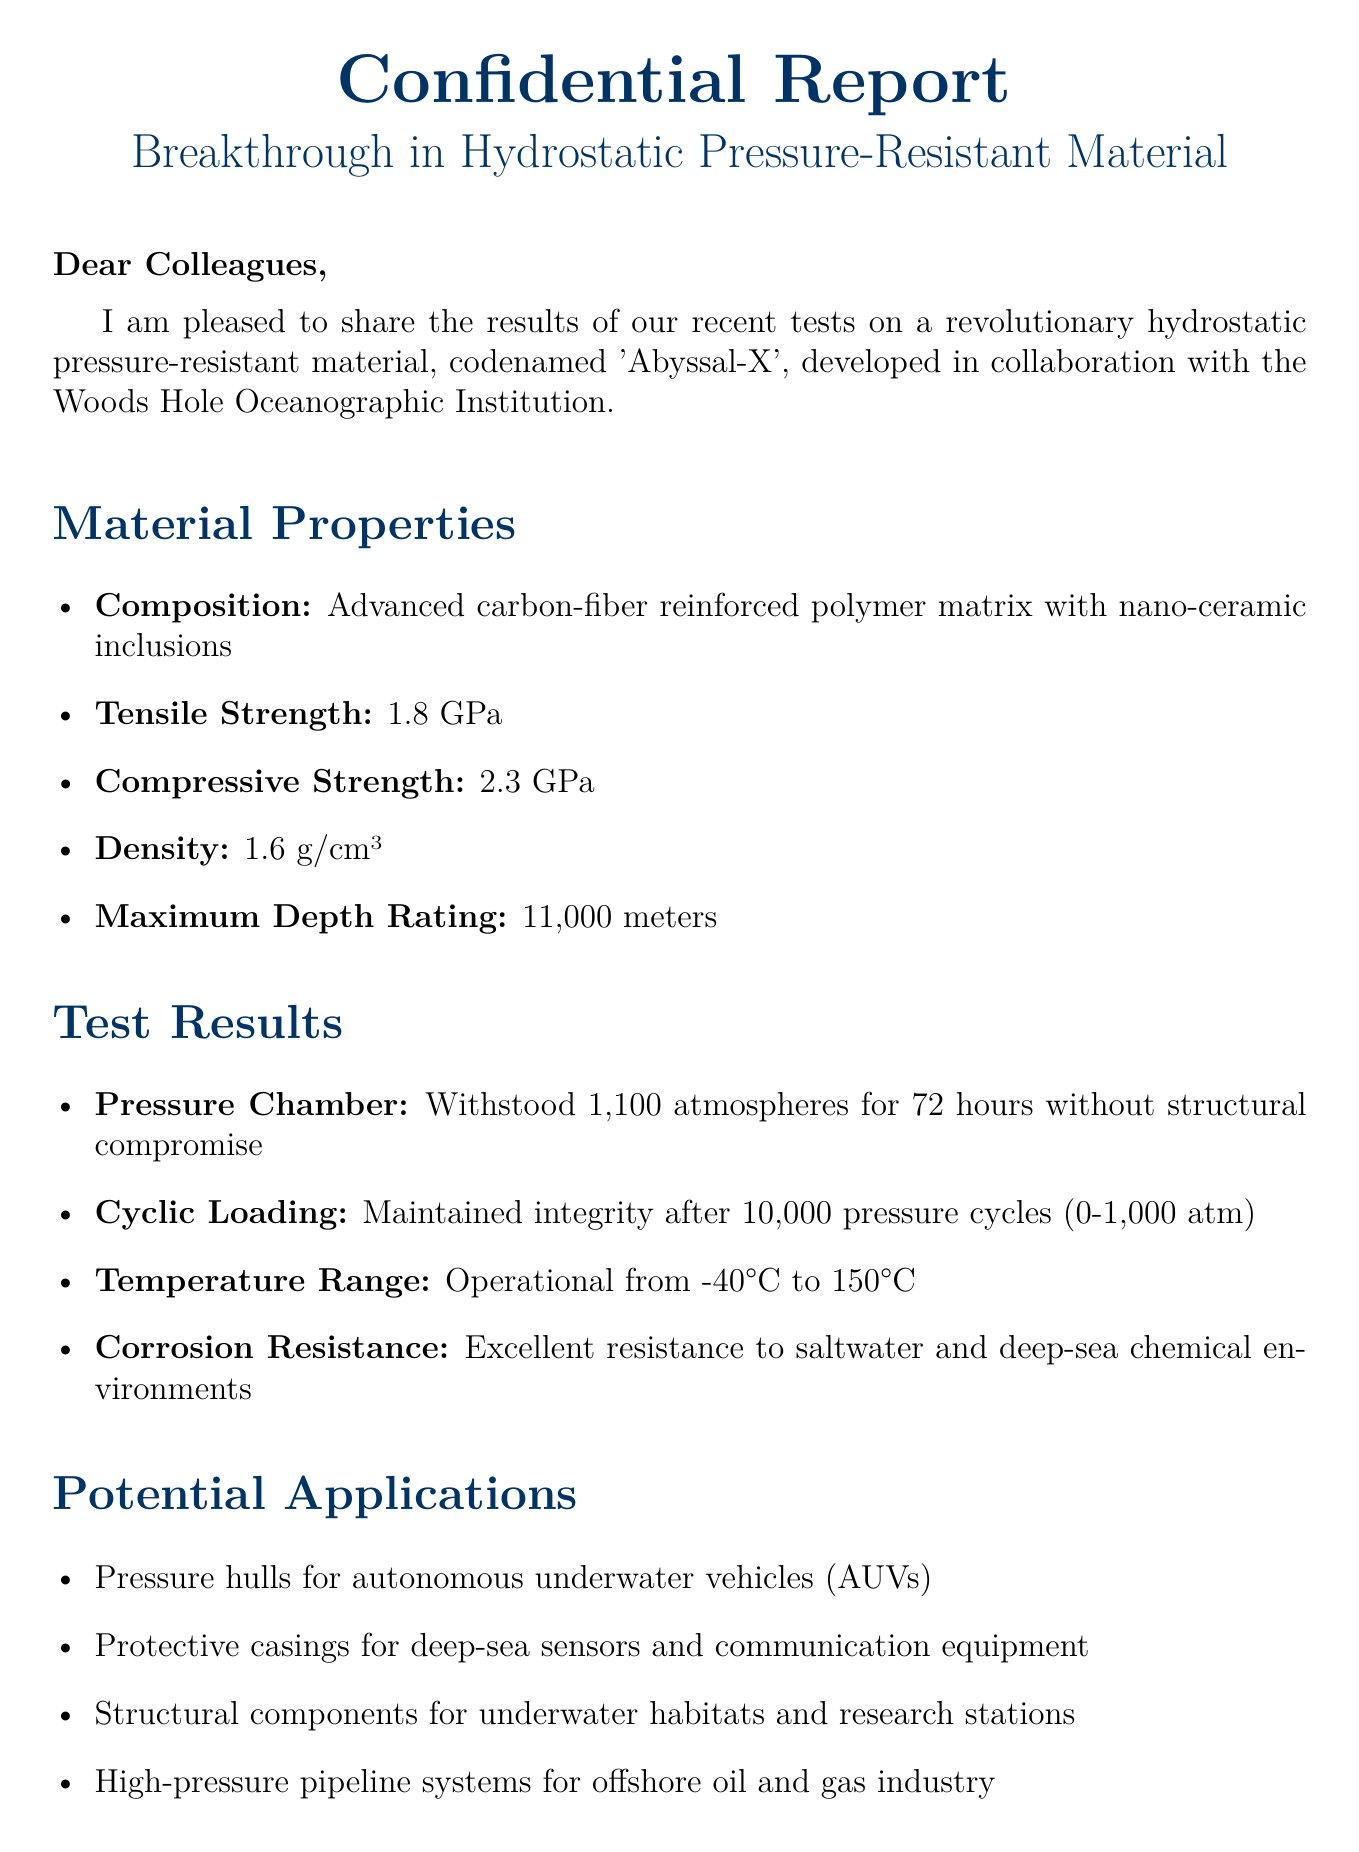What is the name of the new material? The new material is codenamed 'Abyssal-X'.
Answer: 'Abyssal-X' What is the maximum depth rating of the material? The document states that the maximum depth rating is 11,000 meters.
Answer: 11,000 meters What is the tensile strength of the material? The tensile strength mentioned in the document is 1.8 GPa.
Answer: 1.8 GPa How many pressure cycles did the material maintain integrity after? The material maintained integrity after 10,000 pressure cycles.
Answer: 10,000 What is one potential application for the material? One potential application mentioned is pressure hulls for AUVs.
Answer: Pressure hulls for autonomous underwater vehicles (AUVs) What is the operational temperature range of the material? The operational temperature range is from -40°C to 150°C.
Answer: -40°C to 150°C What future step involves field trials? The future step is to conduct field trials using the Alvin submersible in the Mariana Trench.
Answer: Conduct field trials using the Alvin submersible in the Mariana Trench What type of collaborations are being explored for future development? The document discusses exploring potential partnerships with companies like Oceaneering International and Subsea 7.
Answer: Partnerships with companies like Oceaneering International and Subsea 7 What is the closing remark about the breakthrough? The closing remark states that it has the potential to revolutionize deep-sea exploration and underwater robotics.
Answer: Revolutionize deep-sea exploration and underwater robotics 